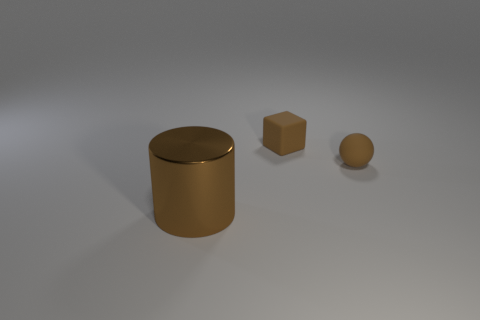Is there anything else that has the same material as the large brown object?
Your answer should be very brief. No. There is a brown thing that is both to the left of the brown ball and behind the large cylinder; what size is it?
Offer a very short reply. Small. There is a brown thing that is both in front of the matte cube and behind the big metallic thing; what shape is it?
Offer a terse response. Sphere. Is the number of large brown metal things that are on the right side of the rubber block the same as the number of big brown metallic objects left of the big brown cylinder?
Provide a succinct answer. Yes. There is a ball that is the same size as the matte block; what color is it?
Your answer should be very brief. Brown. Is there a brown rubber thing to the left of the cube to the left of the tiny brown thing in front of the small rubber cube?
Offer a terse response. No. Is there anything else that is the same color as the cube?
Offer a very short reply. Yes. How big is the rubber thing that is on the right side of the matte block?
Give a very brief answer. Small. What is the size of the brown object that is left of the small brown thing left of the small brown object that is to the right of the tiny matte cube?
Offer a very short reply. Large. There is a metallic object that is in front of the small rubber object left of the sphere; what is its color?
Offer a terse response. Brown. 